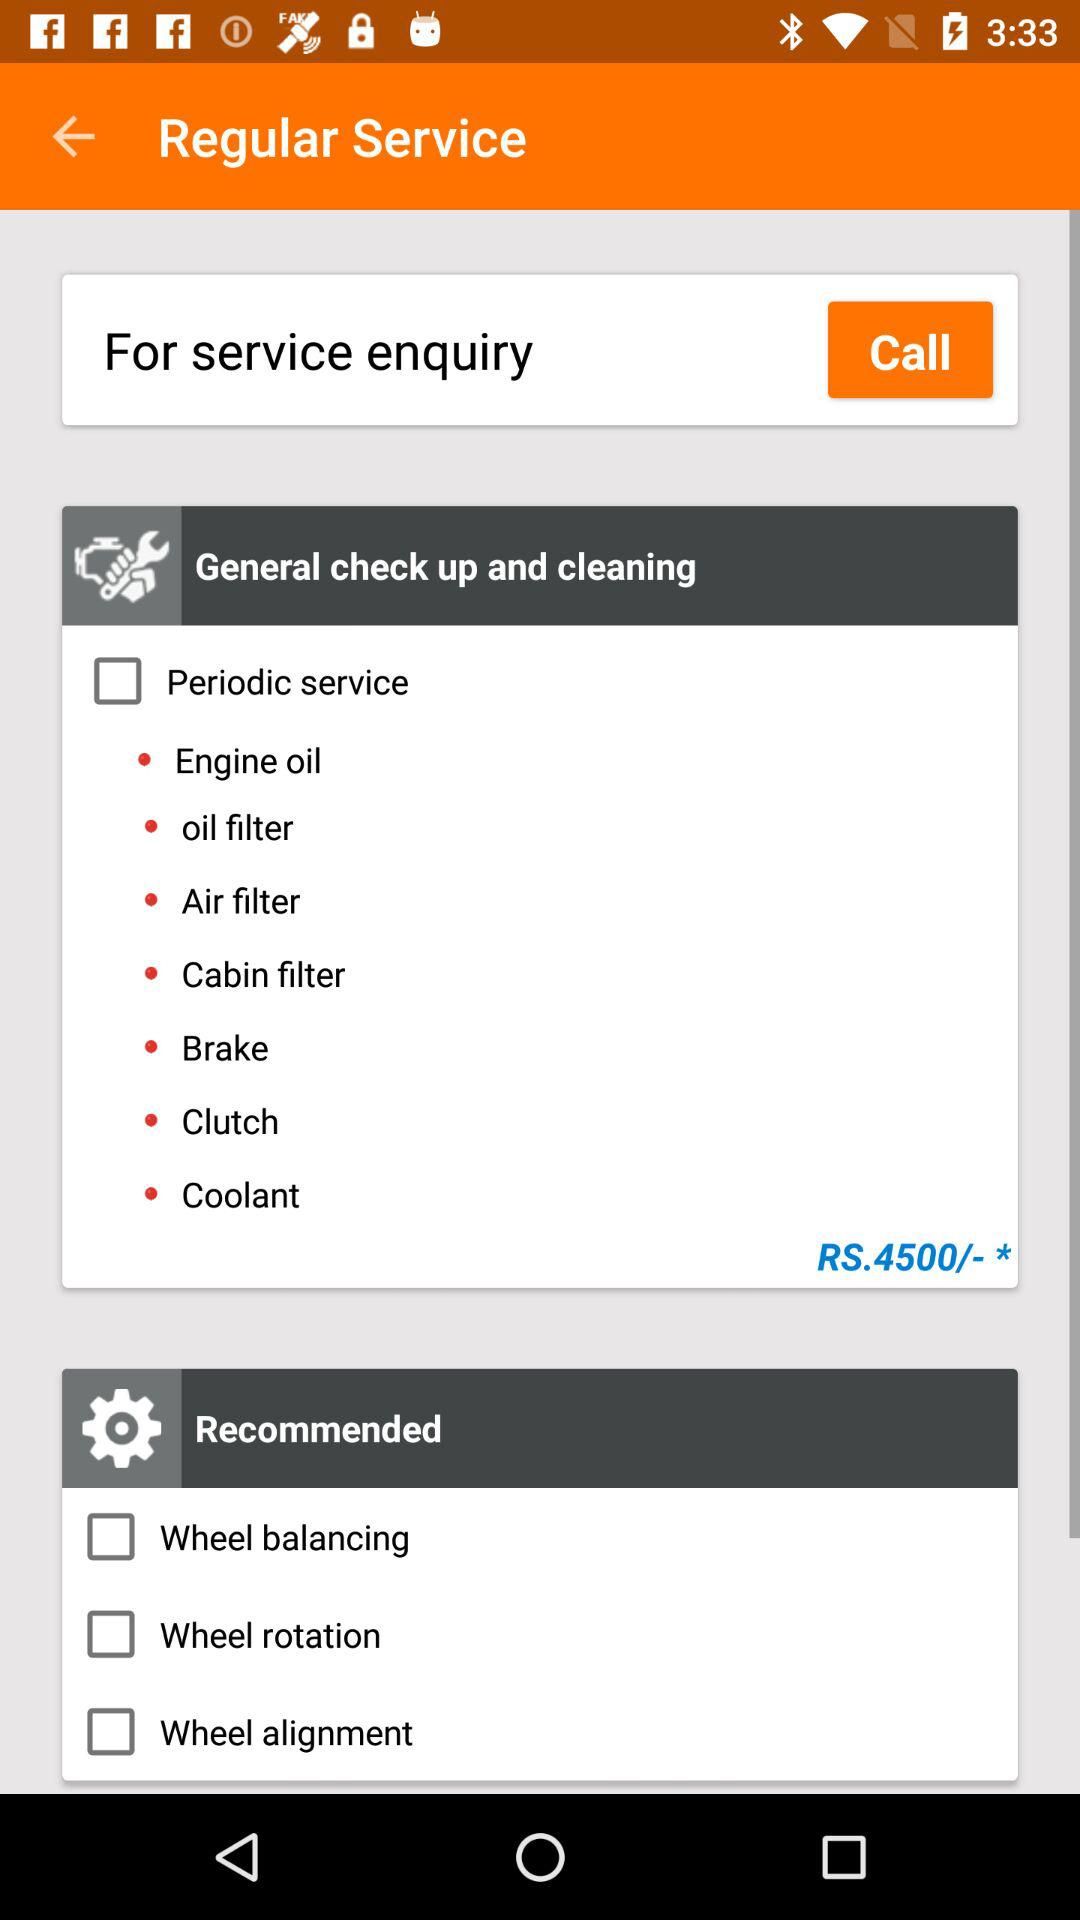How much is the fee for periodic service in USD?
When the provided information is insufficient, respond with <no answer>. <no answer> 